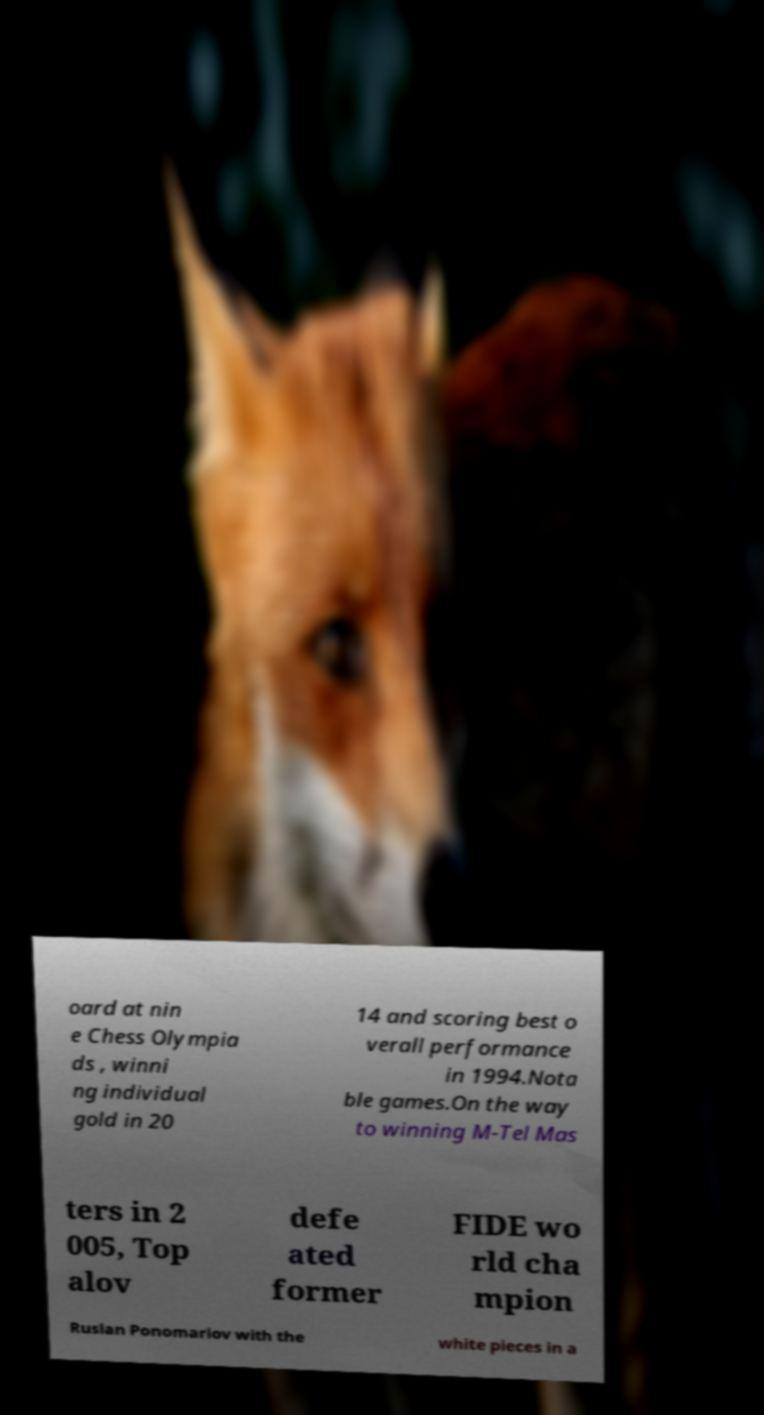Can you accurately transcribe the text from the provided image for me? oard at nin e Chess Olympia ds , winni ng individual gold in 20 14 and scoring best o verall performance in 1994.Nota ble games.On the way to winning M-Tel Mas ters in 2 005, Top alov defe ated former FIDE wo rld cha mpion Ruslan Ponomariov with the white pieces in a 